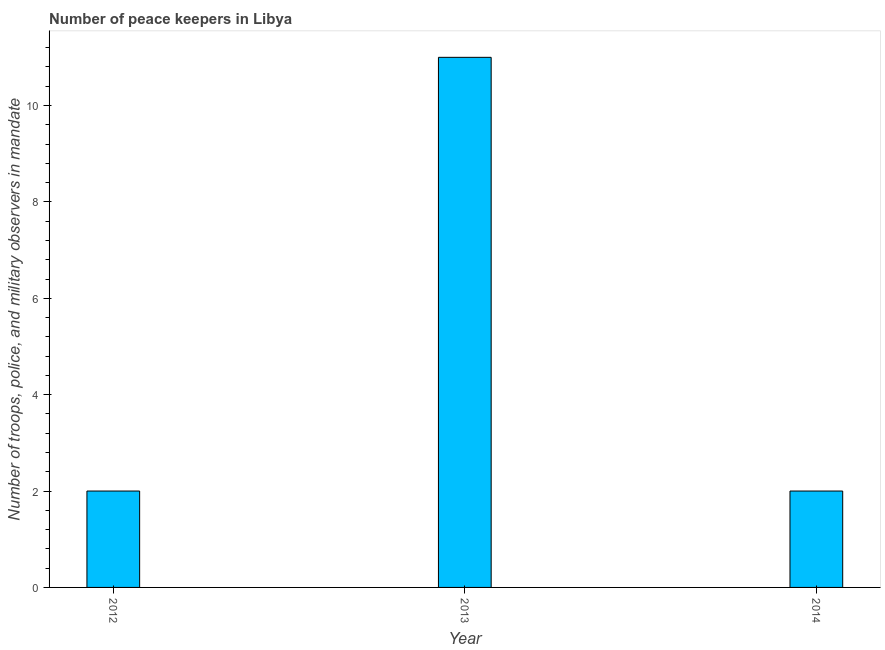What is the title of the graph?
Give a very brief answer. Number of peace keepers in Libya. What is the label or title of the X-axis?
Provide a succinct answer. Year. What is the label or title of the Y-axis?
Your answer should be compact. Number of troops, police, and military observers in mandate. What is the number of peace keepers in 2014?
Provide a short and direct response. 2. Across all years, what is the maximum number of peace keepers?
Your response must be concise. 11. Across all years, what is the minimum number of peace keepers?
Provide a succinct answer. 2. In which year was the number of peace keepers maximum?
Make the answer very short. 2013. What is the sum of the number of peace keepers?
Make the answer very short. 15. What is the average number of peace keepers per year?
Your answer should be compact. 5. In how many years, is the number of peace keepers greater than 4.4 ?
Your answer should be very brief. 1. Do a majority of the years between 2013 and 2012 (inclusive) have number of peace keepers greater than 4 ?
Give a very brief answer. No. What is the ratio of the number of peace keepers in 2013 to that in 2014?
Keep it short and to the point. 5.5. What is the difference between the highest and the second highest number of peace keepers?
Provide a short and direct response. 9. Is the sum of the number of peace keepers in 2012 and 2014 greater than the maximum number of peace keepers across all years?
Offer a terse response. No. What is the difference between the highest and the lowest number of peace keepers?
Your response must be concise. 9. In how many years, is the number of peace keepers greater than the average number of peace keepers taken over all years?
Offer a terse response. 1. How many bars are there?
Provide a short and direct response. 3. How many years are there in the graph?
Make the answer very short. 3. Are the values on the major ticks of Y-axis written in scientific E-notation?
Provide a succinct answer. No. What is the Number of troops, police, and military observers in mandate of 2012?
Ensure brevity in your answer.  2. What is the Number of troops, police, and military observers in mandate in 2013?
Provide a succinct answer. 11. What is the difference between the Number of troops, police, and military observers in mandate in 2012 and 2013?
Offer a very short reply. -9. What is the ratio of the Number of troops, police, and military observers in mandate in 2012 to that in 2013?
Give a very brief answer. 0.18. 